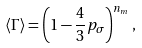<formula> <loc_0><loc_0><loc_500><loc_500>\left < \Gamma \right > = \left ( 1 - \frac { 4 } { 3 } p _ { \sigma } \right ) ^ { n _ { m } } ,</formula> 